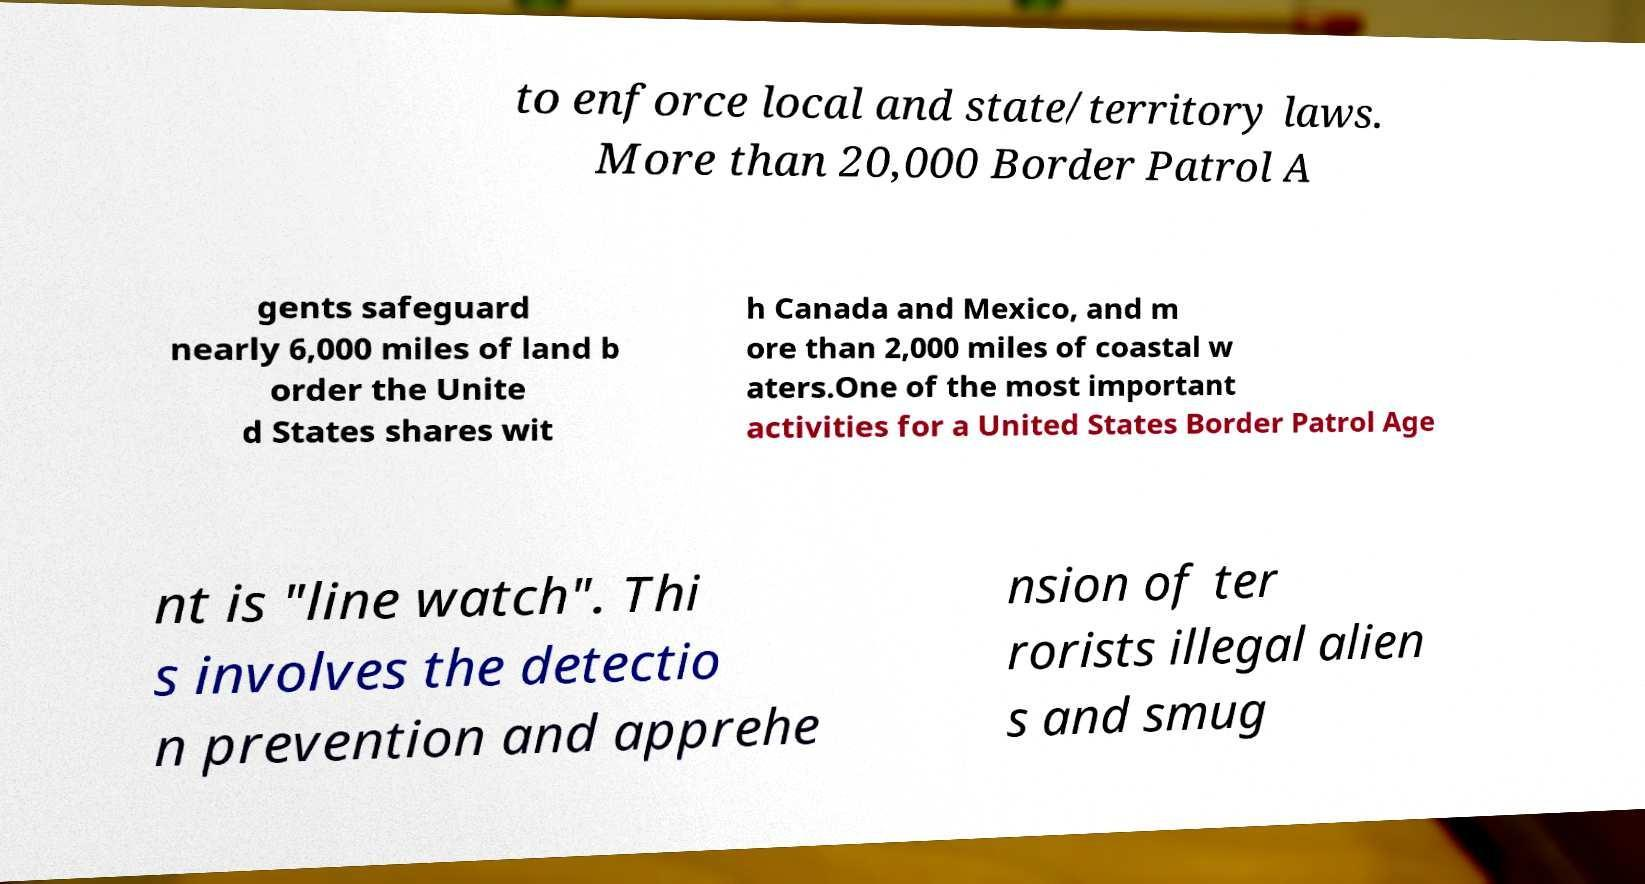Please read and relay the text visible in this image. What does it say? to enforce local and state/territory laws. More than 20,000 Border Patrol A gents safeguard nearly 6,000 miles of land b order the Unite d States shares wit h Canada and Mexico, and m ore than 2,000 miles of coastal w aters.One of the most important activities for a United States Border Patrol Age nt is "line watch". Thi s involves the detectio n prevention and apprehe nsion of ter rorists illegal alien s and smug 